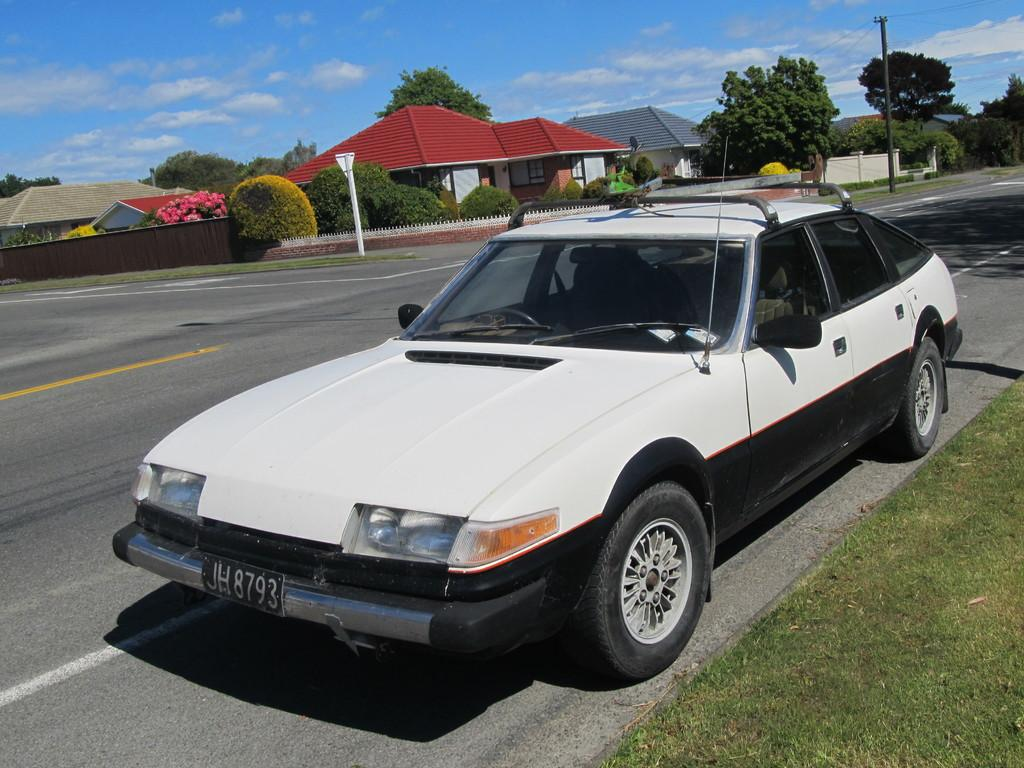What is the main subject in the foreground of the image? There is a car on the road in the foreground of the image. What type of landscape can be seen on the right side of the image? There is a grassland on the right side of the image. What can be seen in the background of the image? There are roads, houses, trees, poles, and the sky visible in the background of the image. What suggestion does the car give to the trees in the image? The car does not give any suggestions to the trees in the image, as it is an inanimate object and cannot communicate. 